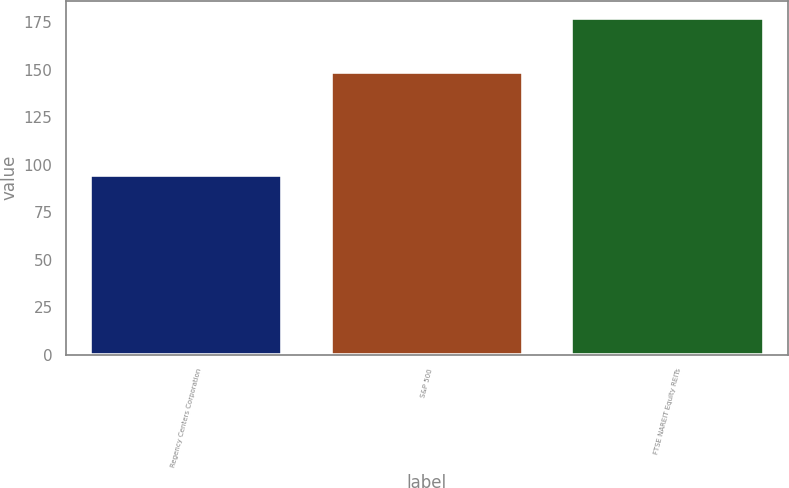Convert chart to OTSL. <chart><loc_0><loc_0><loc_500><loc_500><bar_chart><fcel>Regency Centers Corporation<fcel>S&P 500<fcel>FTSE NAREIT Equity REITs<nl><fcel>94.65<fcel>148.59<fcel>177.36<nl></chart> 